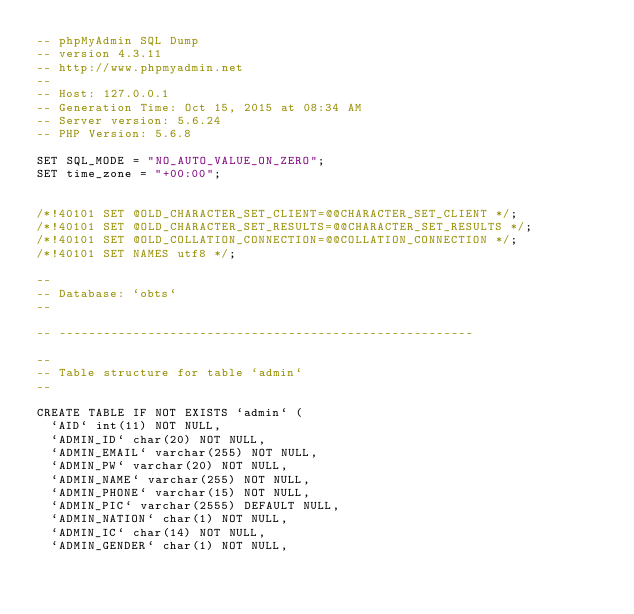<code> <loc_0><loc_0><loc_500><loc_500><_SQL_>-- phpMyAdmin SQL Dump
-- version 4.3.11
-- http://www.phpmyadmin.net
--
-- Host: 127.0.0.1
-- Generation Time: Oct 15, 2015 at 08:34 AM
-- Server version: 5.6.24
-- PHP Version: 5.6.8

SET SQL_MODE = "NO_AUTO_VALUE_ON_ZERO";
SET time_zone = "+00:00";


/*!40101 SET @OLD_CHARACTER_SET_CLIENT=@@CHARACTER_SET_CLIENT */;
/*!40101 SET @OLD_CHARACTER_SET_RESULTS=@@CHARACTER_SET_RESULTS */;
/*!40101 SET @OLD_COLLATION_CONNECTION=@@COLLATION_CONNECTION */;
/*!40101 SET NAMES utf8 */;

--
-- Database: `obts`
--

-- --------------------------------------------------------

--
-- Table structure for table `admin`
--

CREATE TABLE IF NOT EXISTS `admin` (
  `AID` int(11) NOT NULL,
  `ADMIN_ID` char(20) NOT NULL,
  `ADMIN_EMAIL` varchar(255) NOT NULL,
  `ADMIN_PW` varchar(20) NOT NULL,
  `ADMIN_NAME` varchar(255) NOT NULL,
  `ADMIN_PHONE` varchar(15) NOT NULL,
  `ADMIN_PIC` varchar(2555) DEFAULT NULL,
  `ADMIN_NATION` char(1) NOT NULL,
  `ADMIN_IC` char(14) NOT NULL,
  `ADMIN_GENDER` char(1) NOT NULL,</code> 